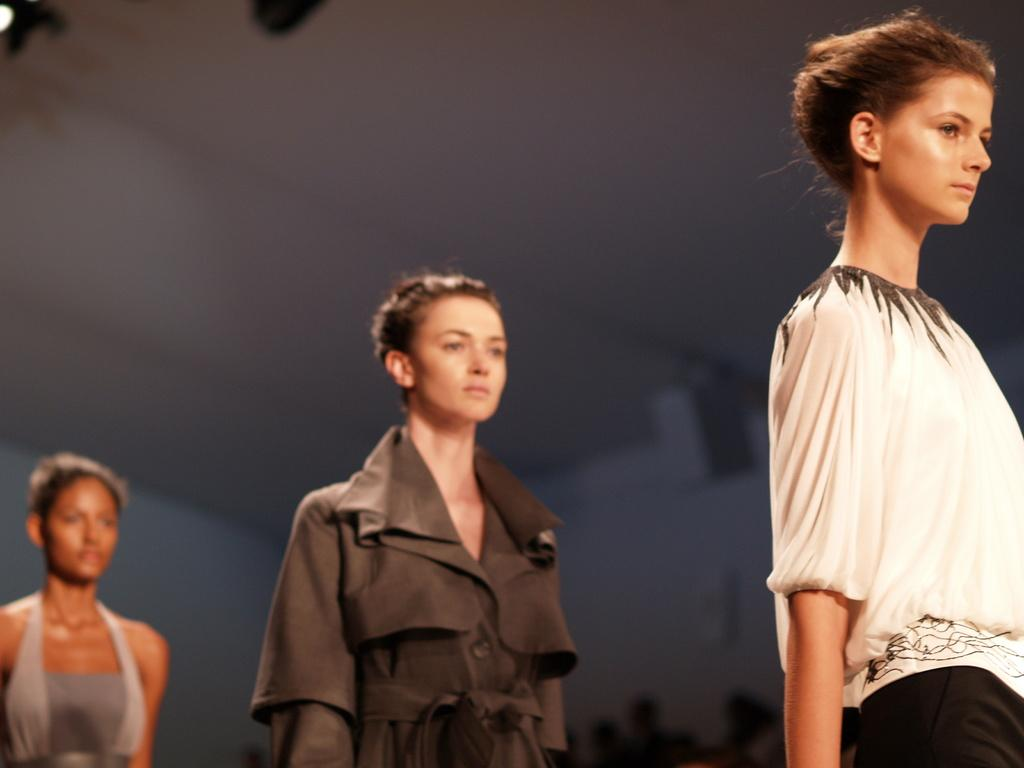How many women are in the front of the image? There are three women in the front of the image. What can be observed about the background of the image? The background of the image is blurry. What type of agreement did the women reach in the image? There is no indication in the image that the women reached any agreement, as the image only shows them in the front and does not provide any context for their actions or interactions. 